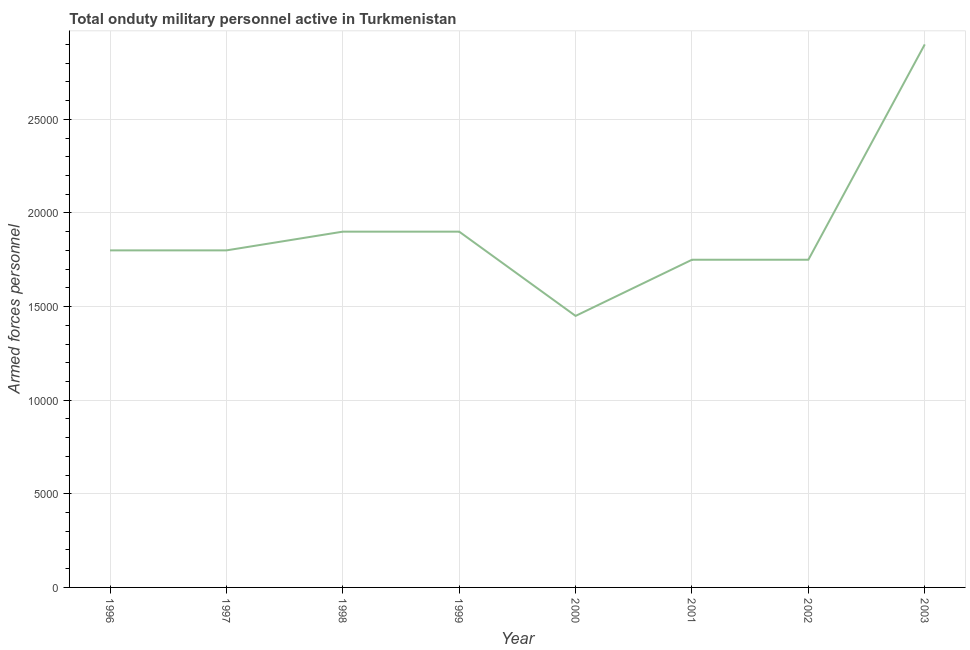What is the number of armed forces personnel in 2002?
Provide a short and direct response. 1.75e+04. Across all years, what is the maximum number of armed forces personnel?
Give a very brief answer. 2.90e+04. Across all years, what is the minimum number of armed forces personnel?
Provide a succinct answer. 1.45e+04. What is the sum of the number of armed forces personnel?
Your answer should be very brief. 1.52e+05. What is the difference between the number of armed forces personnel in 1996 and 1998?
Your answer should be very brief. -1000. What is the average number of armed forces personnel per year?
Provide a short and direct response. 1.91e+04. What is the median number of armed forces personnel?
Offer a very short reply. 1.80e+04. What is the ratio of the number of armed forces personnel in 1999 to that in 2001?
Make the answer very short. 1.09. Is the number of armed forces personnel in 1996 less than that in 2002?
Offer a terse response. No. Is the difference between the number of armed forces personnel in 1997 and 2000 greater than the difference between any two years?
Your answer should be very brief. No. Is the sum of the number of armed forces personnel in 2000 and 2001 greater than the maximum number of armed forces personnel across all years?
Your answer should be compact. Yes. What is the difference between the highest and the lowest number of armed forces personnel?
Ensure brevity in your answer.  1.45e+04. In how many years, is the number of armed forces personnel greater than the average number of armed forces personnel taken over all years?
Make the answer very short. 1. Does the number of armed forces personnel monotonically increase over the years?
Your answer should be compact. No. How many years are there in the graph?
Offer a terse response. 8. Are the values on the major ticks of Y-axis written in scientific E-notation?
Offer a very short reply. No. Does the graph contain any zero values?
Offer a terse response. No. What is the title of the graph?
Make the answer very short. Total onduty military personnel active in Turkmenistan. What is the label or title of the X-axis?
Provide a short and direct response. Year. What is the label or title of the Y-axis?
Provide a short and direct response. Armed forces personnel. What is the Armed forces personnel of 1996?
Provide a short and direct response. 1.80e+04. What is the Armed forces personnel of 1997?
Keep it short and to the point. 1.80e+04. What is the Armed forces personnel of 1998?
Provide a short and direct response. 1.90e+04. What is the Armed forces personnel of 1999?
Your answer should be very brief. 1.90e+04. What is the Armed forces personnel of 2000?
Offer a terse response. 1.45e+04. What is the Armed forces personnel of 2001?
Provide a succinct answer. 1.75e+04. What is the Armed forces personnel in 2002?
Ensure brevity in your answer.  1.75e+04. What is the Armed forces personnel of 2003?
Offer a terse response. 2.90e+04. What is the difference between the Armed forces personnel in 1996 and 1997?
Offer a terse response. 0. What is the difference between the Armed forces personnel in 1996 and 1998?
Give a very brief answer. -1000. What is the difference between the Armed forces personnel in 1996 and 1999?
Your answer should be compact. -1000. What is the difference between the Armed forces personnel in 1996 and 2000?
Provide a succinct answer. 3500. What is the difference between the Armed forces personnel in 1996 and 2002?
Give a very brief answer. 500. What is the difference between the Armed forces personnel in 1996 and 2003?
Give a very brief answer. -1.10e+04. What is the difference between the Armed forces personnel in 1997 and 1998?
Your answer should be compact. -1000. What is the difference between the Armed forces personnel in 1997 and 1999?
Your response must be concise. -1000. What is the difference between the Armed forces personnel in 1997 and 2000?
Your answer should be very brief. 3500. What is the difference between the Armed forces personnel in 1997 and 2002?
Your response must be concise. 500. What is the difference between the Armed forces personnel in 1997 and 2003?
Provide a succinct answer. -1.10e+04. What is the difference between the Armed forces personnel in 1998 and 2000?
Provide a succinct answer. 4500. What is the difference between the Armed forces personnel in 1998 and 2001?
Make the answer very short. 1500. What is the difference between the Armed forces personnel in 1998 and 2002?
Keep it short and to the point. 1500. What is the difference between the Armed forces personnel in 1998 and 2003?
Make the answer very short. -10000. What is the difference between the Armed forces personnel in 1999 and 2000?
Offer a terse response. 4500. What is the difference between the Armed forces personnel in 1999 and 2001?
Offer a very short reply. 1500. What is the difference between the Armed forces personnel in 1999 and 2002?
Provide a succinct answer. 1500. What is the difference between the Armed forces personnel in 2000 and 2001?
Offer a terse response. -3000. What is the difference between the Armed forces personnel in 2000 and 2002?
Your answer should be compact. -3000. What is the difference between the Armed forces personnel in 2000 and 2003?
Your answer should be very brief. -1.45e+04. What is the difference between the Armed forces personnel in 2001 and 2003?
Provide a short and direct response. -1.15e+04. What is the difference between the Armed forces personnel in 2002 and 2003?
Offer a very short reply. -1.15e+04. What is the ratio of the Armed forces personnel in 1996 to that in 1998?
Your answer should be very brief. 0.95. What is the ratio of the Armed forces personnel in 1996 to that in 1999?
Your answer should be compact. 0.95. What is the ratio of the Armed forces personnel in 1996 to that in 2000?
Ensure brevity in your answer.  1.24. What is the ratio of the Armed forces personnel in 1996 to that in 2002?
Your response must be concise. 1.03. What is the ratio of the Armed forces personnel in 1996 to that in 2003?
Your response must be concise. 0.62. What is the ratio of the Armed forces personnel in 1997 to that in 1998?
Your answer should be compact. 0.95. What is the ratio of the Armed forces personnel in 1997 to that in 1999?
Offer a terse response. 0.95. What is the ratio of the Armed forces personnel in 1997 to that in 2000?
Give a very brief answer. 1.24. What is the ratio of the Armed forces personnel in 1997 to that in 2001?
Offer a very short reply. 1.03. What is the ratio of the Armed forces personnel in 1997 to that in 2002?
Ensure brevity in your answer.  1.03. What is the ratio of the Armed forces personnel in 1997 to that in 2003?
Make the answer very short. 0.62. What is the ratio of the Armed forces personnel in 1998 to that in 1999?
Ensure brevity in your answer.  1. What is the ratio of the Armed forces personnel in 1998 to that in 2000?
Provide a short and direct response. 1.31. What is the ratio of the Armed forces personnel in 1998 to that in 2001?
Your answer should be compact. 1.09. What is the ratio of the Armed forces personnel in 1998 to that in 2002?
Your answer should be very brief. 1.09. What is the ratio of the Armed forces personnel in 1998 to that in 2003?
Offer a terse response. 0.66. What is the ratio of the Armed forces personnel in 1999 to that in 2000?
Your answer should be compact. 1.31. What is the ratio of the Armed forces personnel in 1999 to that in 2001?
Ensure brevity in your answer.  1.09. What is the ratio of the Armed forces personnel in 1999 to that in 2002?
Keep it short and to the point. 1.09. What is the ratio of the Armed forces personnel in 1999 to that in 2003?
Your response must be concise. 0.66. What is the ratio of the Armed forces personnel in 2000 to that in 2001?
Ensure brevity in your answer.  0.83. What is the ratio of the Armed forces personnel in 2000 to that in 2002?
Make the answer very short. 0.83. What is the ratio of the Armed forces personnel in 2000 to that in 2003?
Provide a succinct answer. 0.5. What is the ratio of the Armed forces personnel in 2001 to that in 2002?
Offer a terse response. 1. What is the ratio of the Armed forces personnel in 2001 to that in 2003?
Your response must be concise. 0.6. What is the ratio of the Armed forces personnel in 2002 to that in 2003?
Provide a short and direct response. 0.6. 